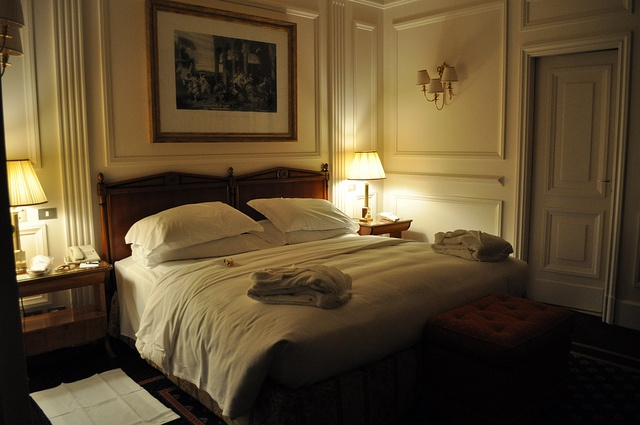Describe the objects in this image and their specific colors. I can see a bed in black, olive, tan, and maroon tones in this image. 